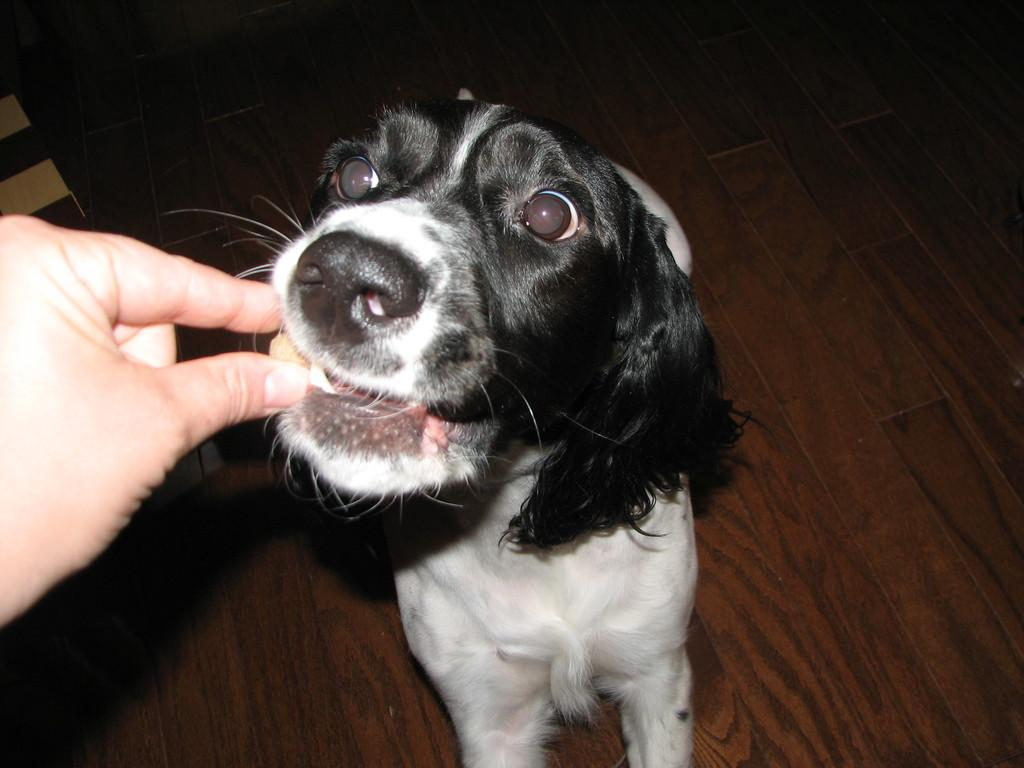What is happening in the image? There is a person in the image who is feeding a dog. What surface is visible in the image? There is a floor visible in the image. How many girls are laughing on the bed in the image? There are no girls or beds present in the image. 